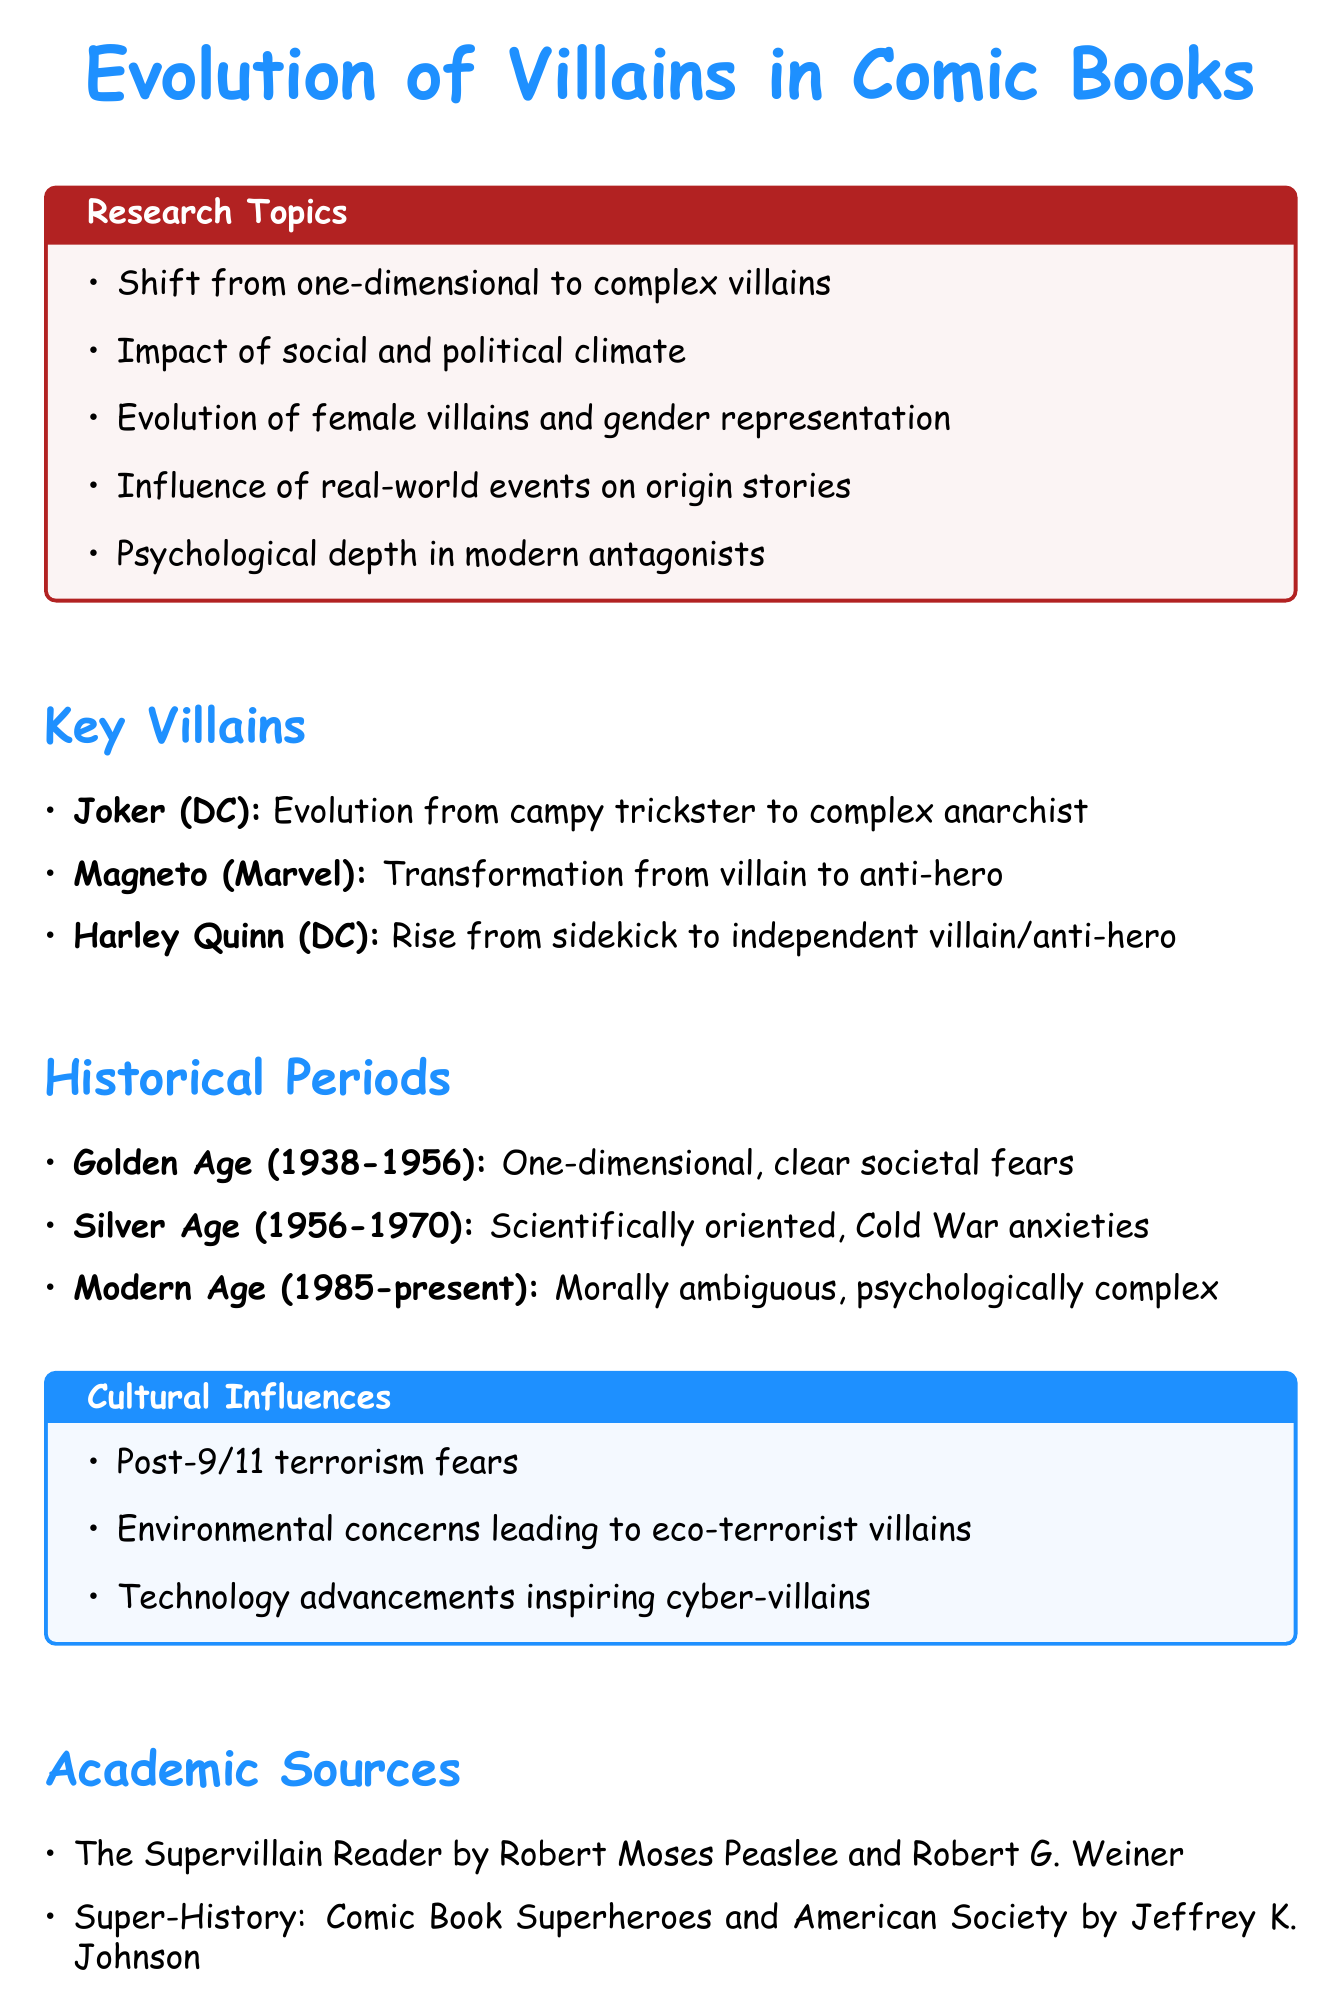What is the focus of the research paper? The document highlights the "Evolution of Villains in Comic Books" as the central theme.
Answer: Evolution of Villains in Comic Books Name a key villain that has transformed into an anti-hero. The document mentions Magneto as a villain who evolved into an anti-hero, reflecting changes in social attitudes.
Answer: Magneto What era characterized morally ambiguous villains? The "Modern Age (1985-present)" is identified in the document as the period when villains became morally ambiguous and psychologically complex.
Answer: Modern Age (1985-present) Which cultural influence relates to post-9/11 events? The document notes that "Post-9/11 terrorism fears" have significantly shaped villain motivations.
Answer: Post-9/11 terrorism fears Who are the authors of the academic source titled "The Supervillain Reader"? The document lists Robert Moses Peaslee and Robert G. Weiner as the authors.
Answer: Robert Moses Peaslee and Robert G. Weiner 